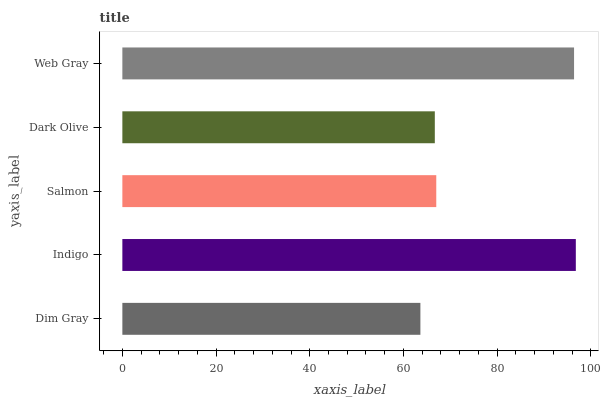Is Dim Gray the minimum?
Answer yes or no. Yes. Is Indigo the maximum?
Answer yes or no. Yes. Is Salmon the minimum?
Answer yes or no. No. Is Salmon the maximum?
Answer yes or no. No. Is Indigo greater than Salmon?
Answer yes or no. Yes. Is Salmon less than Indigo?
Answer yes or no. Yes. Is Salmon greater than Indigo?
Answer yes or no. No. Is Indigo less than Salmon?
Answer yes or no. No. Is Salmon the high median?
Answer yes or no. Yes. Is Salmon the low median?
Answer yes or no. Yes. Is Web Gray the high median?
Answer yes or no. No. Is Indigo the low median?
Answer yes or no. No. 